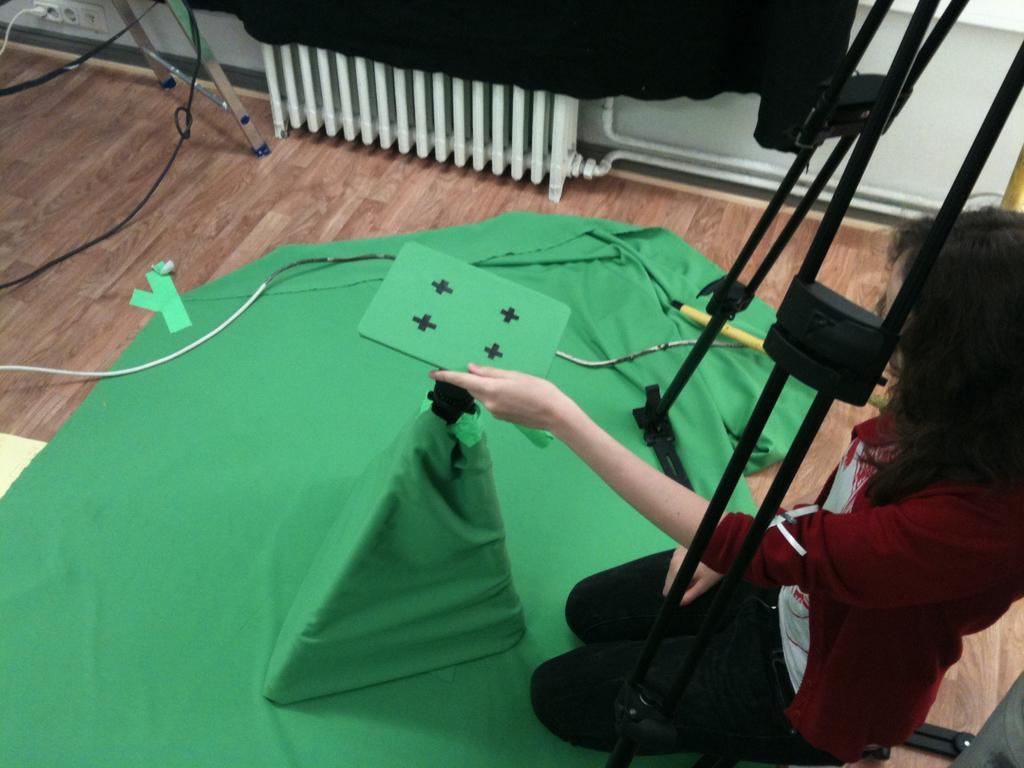Please provide a concise description of this image. On the right side of the image there is a person sitting on the floor and holding and object in the hand. In front of the person on the floor there is a cloth. And also there is an object on the cloth. There are black color stands on the right side of the image. At the top of the image there is a wall with cloth, pipes, switch board with a wire connected to it. And also there are wires on the floor. 